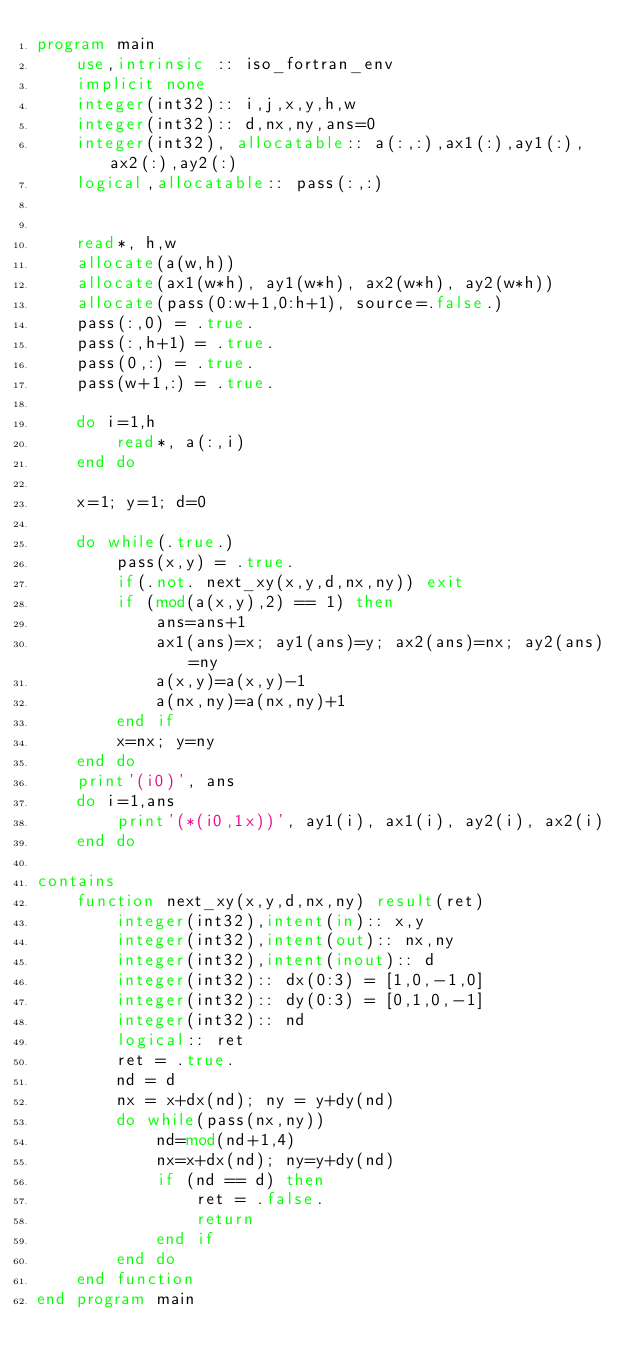Convert code to text. <code><loc_0><loc_0><loc_500><loc_500><_FORTRAN_>program main
    use,intrinsic :: iso_fortran_env
    implicit none
    integer(int32):: i,j,x,y,h,w
    integer(int32):: d,nx,ny,ans=0
    integer(int32), allocatable:: a(:,:),ax1(:),ay1(:),ax2(:),ay2(:)
    logical,allocatable:: pass(:,:)


    read*, h,w
    allocate(a(w,h))
    allocate(ax1(w*h), ay1(w*h), ax2(w*h), ay2(w*h))
    allocate(pass(0:w+1,0:h+1), source=.false.)
    pass(:,0) = .true.
    pass(:,h+1) = .true.
    pass(0,:) = .true.
    pass(w+1,:) = .true.

    do i=1,h
        read*, a(:,i)
    end do

    x=1; y=1; d=0

    do while(.true.)
        pass(x,y) = .true.
        if(.not. next_xy(x,y,d,nx,ny)) exit
        if (mod(a(x,y),2) == 1) then
            ans=ans+1
            ax1(ans)=x; ay1(ans)=y; ax2(ans)=nx; ay2(ans)=ny
            a(x,y)=a(x,y)-1
            a(nx,ny)=a(nx,ny)+1
        end if
        x=nx; y=ny
    end do
    print'(i0)', ans
    do i=1,ans
        print'(*(i0,1x))', ay1(i), ax1(i), ay2(i), ax2(i)
    end do

contains
    function next_xy(x,y,d,nx,ny) result(ret)
        integer(int32),intent(in):: x,y
        integer(int32),intent(out):: nx,ny
        integer(int32),intent(inout):: d
        integer(int32):: dx(0:3) = [1,0,-1,0]
        integer(int32):: dy(0:3) = [0,1,0,-1]
        integer(int32):: nd
        logical:: ret
        ret = .true.
        nd = d
        nx = x+dx(nd); ny = y+dy(nd)
        do while(pass(nx,ny))
            nd=mod(nd+1,4)
            nx=x+dx(nd); ny=y+dy(nd)
            if (nd == d) then
                ret = .false.
                return
            end if
        end do
    end function
end program main</code> 